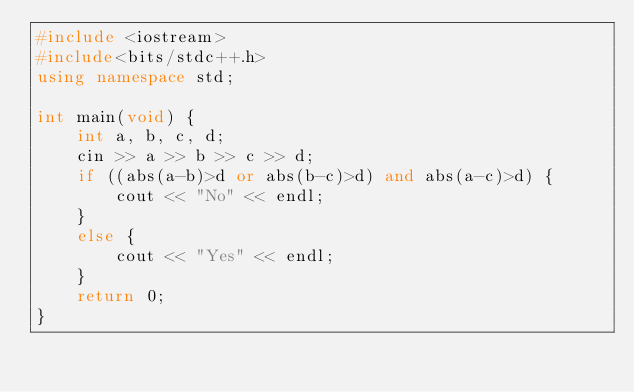Convert code to text. <code><loc_0><loc_0><loc_500><loc_500><_C++_>#include <iostream>
#include<bits/stdc++.h>
using namespace std;

int main(void) {
    int a, b, c, d;
    cin >> a >> b >> c >> d;
    if ((abs(a-b)>d or abs(b-c)>d) and abs(a-c)>d) {
        cout << "No" << endl;
    }
    else {
        cout << "Yes" << endl;
    }
    return 0;
}
</code> 